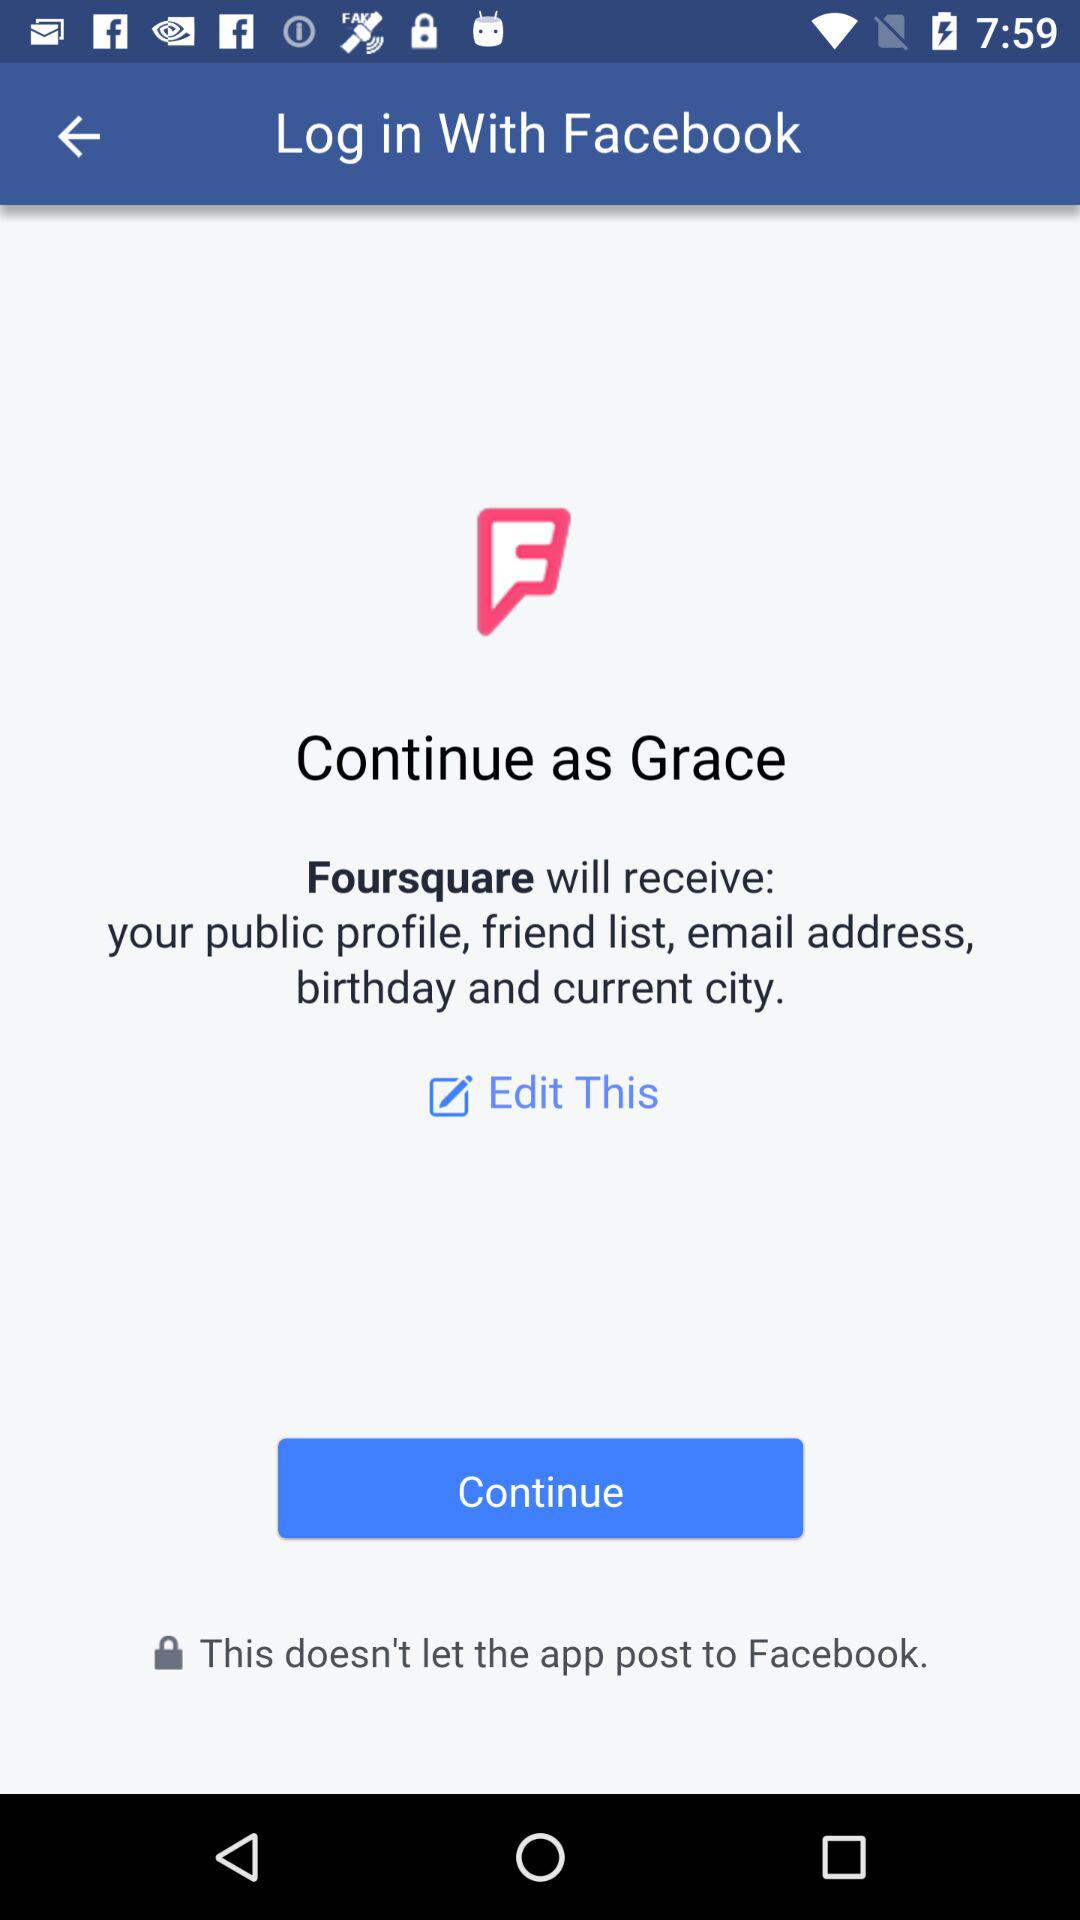Who will receive my public profile, friend list, email address, birthday, and current city? The application that will receive my public profile, friend list, email address, birthday, and current city is "Foursquare". 